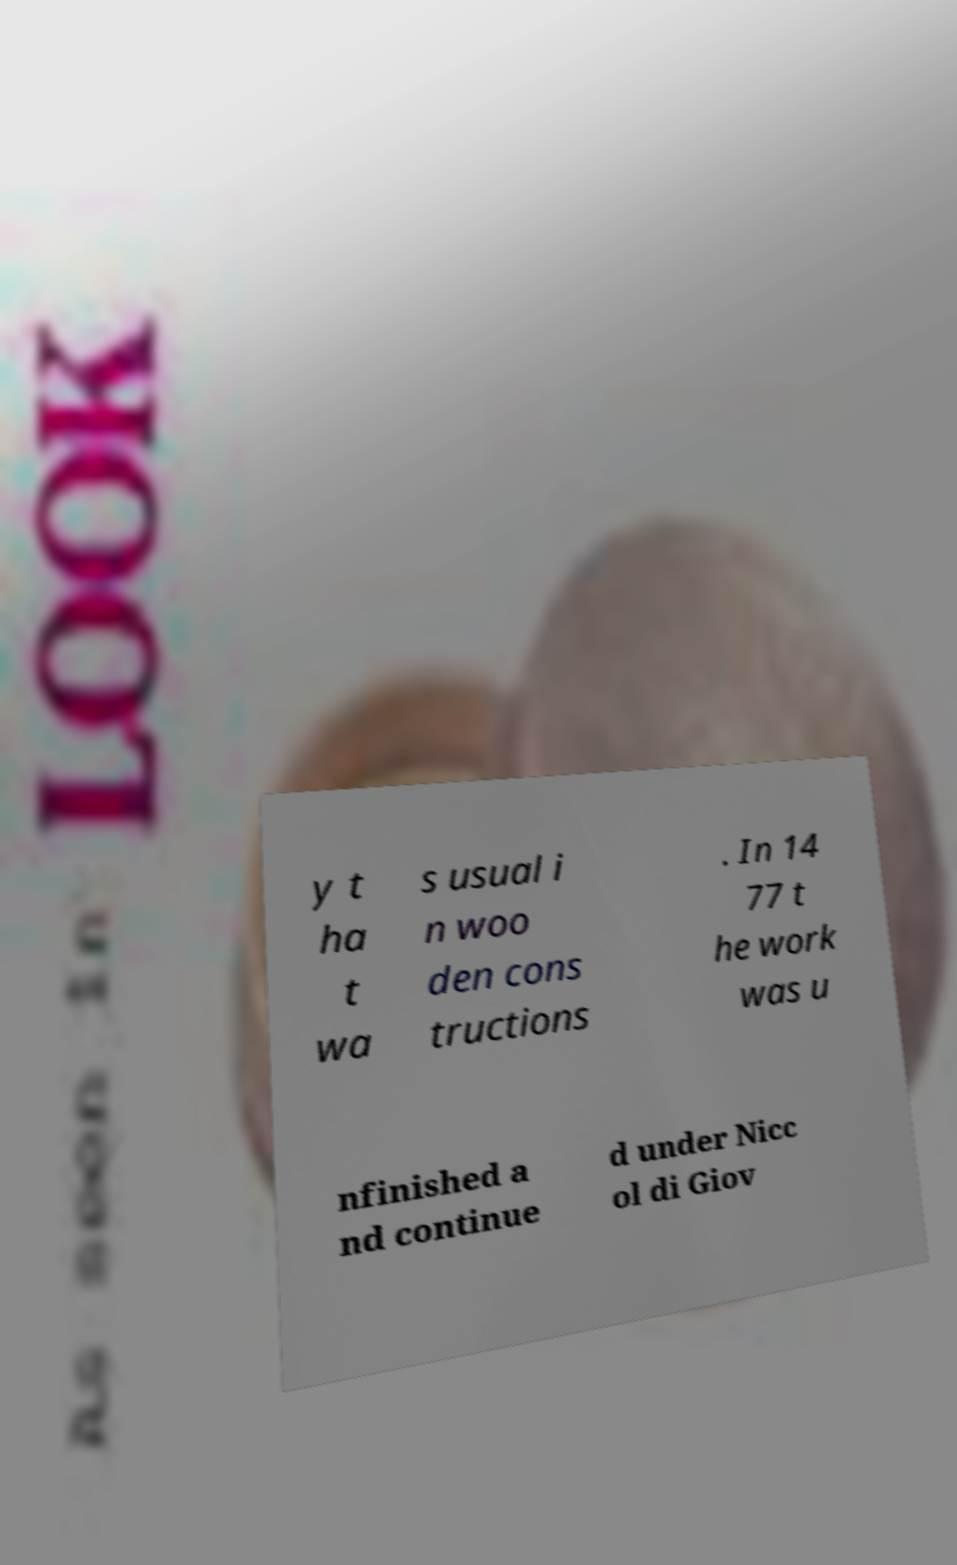For documentation purposes, I need the text within this image transcribed. Could you provide that? y t ha t wa s usual i n woo den cons tructions . In 14 77 t he work was u nfinished a nd continue d under Nicc ol di Giov 